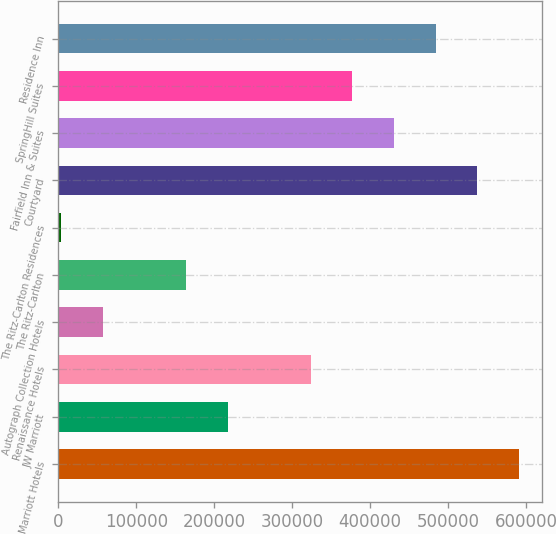Convert chart. <chart><loc_0><loc_0><loc_500><loc_500><bar_chart><fcel>Marriott Hotels<fcel>JW Marriott<fcel>Renaissance Hotels<fcel>Autograph Collection Hotels<fcel>The Ritz-Carlton<fcel>The Ritz-Carlton Residences<fcel>Courtyard<fcel>Fairfield Inn & Suites<fcel>SpringHill Suites<fcel>Residence Inn<nl><fcel>590588<fcel>217049<fcel>323774<fcel>56960.7<fcel>163686<fcel>3598<fcel>537225<fcel>430500<fcel>377137<fcel>483862<nl></chart> 